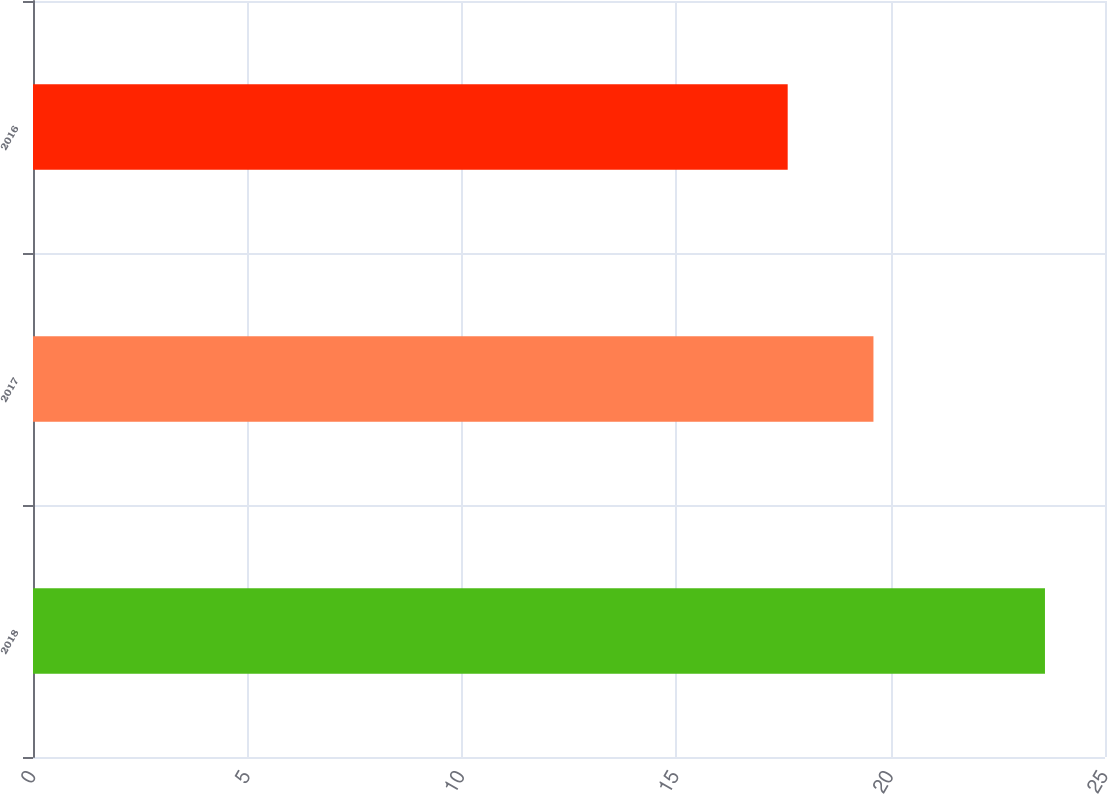<chart> <loc_0><loc_0><loc_500><loc_500><bar_chart><fcel>2018<fcel>2017<fcel>2016<nl><fcel>23.6<fcel>19.6<fcel>17.6<nl></chart> 